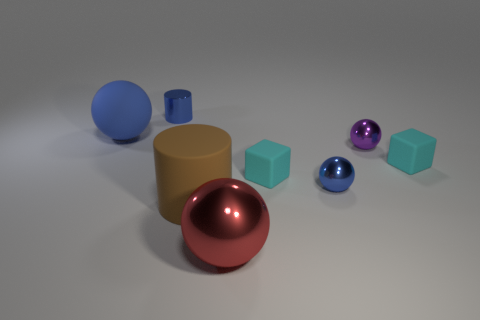How many blue spheres must be subtracted to get 1 blue spheres? 1 Subtract all small blue shiny balls. How many balls are left? 3 Add 2 small purple shiny blocks. How many objects exist? 10 Subtract all blue cylinders. How many cylinders are left? 1 Subtract all brown blocks. How many blue balls are left? 2 Add 1 tiny green things. How many tiny green things exist? 1 Subtract 0 green spheres. How many objects are left? 8 Subtract all cylinders. How many objects are left? 6 Subtract all green cubes. Subtract all cyan cylinders. How many cubes are left? 2 Subtract all small purple things. Subtract all big cylinders. How many objects are left? 6 